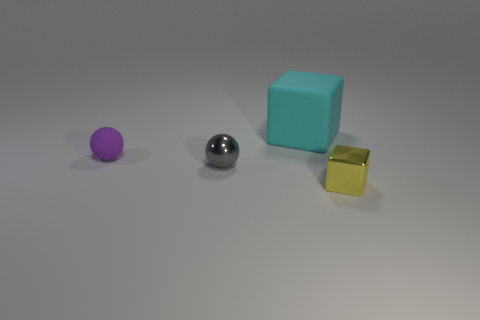Is the number of cyan matte things that are right of the purple thing greater than the number of small purple things that are on the left side of the small gray sphere?
Give a very brief answer. No. How many cubes are to the left of the large cyan rubber block?
Offer a very short reply. 0. Is the material of the cyan object the same as the small ball behind the shiny sphere?
Your answer should be very brief. Yes. Is there anything else that is the same shape as the gray metallic thing?
Your answer should be very brief. Yes. Is the gray object made of the same material as the tiny purple sphere?
Offer a terse response. No. Are there any purple spheres that are behind the metal object left of the yellow metallic thing?
Offer a very short reply. Yes. What number of things are in front of the large rubber thing and right of the small gray thing?
Keep it short and to the point. 1. What shape is the rubber thing that is in front of the big cyan rubber block?
Make the answer very short. Sphere. What number of purple things have the same size as the rubber sphere?
Provide a succinct answer. 0. Does the shiny thing in front of the small metal ball have the same color as the metallic ball?
Give a very brief answer. No. 